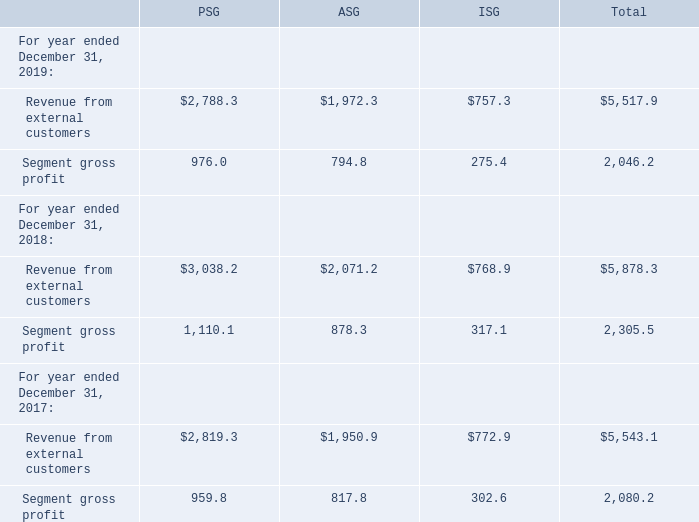Note 3: Revenue and Segment Information
Revenue recognized for sales agreements amounted to $5,492.0 million and $5,849.0 million for the years ended December 31, 2019 and 2018, respectively. Revenue recognized for product development agreements amounted to $25.9 million and $29.3 million for the years ended December 31, 2019 and 2018, respectively.
The Company is organized into three operating and reportable segments consisting of PSG, ASG and ISG. The Company's wafer manufacturing facilities fabricate ICs for all business units, as necessary, and their operating costs are reflected in the segments' cost of revenue on the basis of product costs. Because operating segments are generally defined by the products they design and sell, they do not make sales to each other.
The Company does not allocate income taxes or interest expense to its operating segments as the operating segments are principally evaluated on gross profit. Additionally, restructuring, asset impairments and other charges, net and certain other manufacturing and operating expenses, which include corporate research and development costs, unallocated inventory reserves and miscellaneous nonrecurring expenses, are not allocated to any segment.
In addition to the operating and reportable segments, the Company also operates global operations, sales and marketing, information systems and finance and administration groups. A portion of the expenses of these groups are allocated to the segments based on specific and general criteria and are included in the segment results.
Revenue and gross profit for the Company’s operating and reportable segments are as follows (in millions):
How much Revenue was recognized for sales agreements for the years ended December 31, 2019 and 2018 respectively? $5,492.0 million, $5,849.0 million. How much Revenue was recognized for product development agreements for the years ended December 31, 2019 and 2018 respectively? $25.9 million, $29.3 million. What are the three operating and reportable segments? Psg, asg, isg. What is the change in PSG Revenue from external customers from year ended December 31, 2018 to 2019?
Answer scale should be: million. 2,788.3-3,038.2
Answer: -249.9. What is the change in ASG Revenue from external customers from year ended December 31, 2018 to 2019?
Answer scale should be: million. 1,972.3-2,071.2
Answer: -98.9. What is the average PSG Revenue from external customers for year ended December 31, 2018 to 2019?
Answer scale should be: million. (2,788.3+3,038.2) / 2
Answer: 2913.25. 